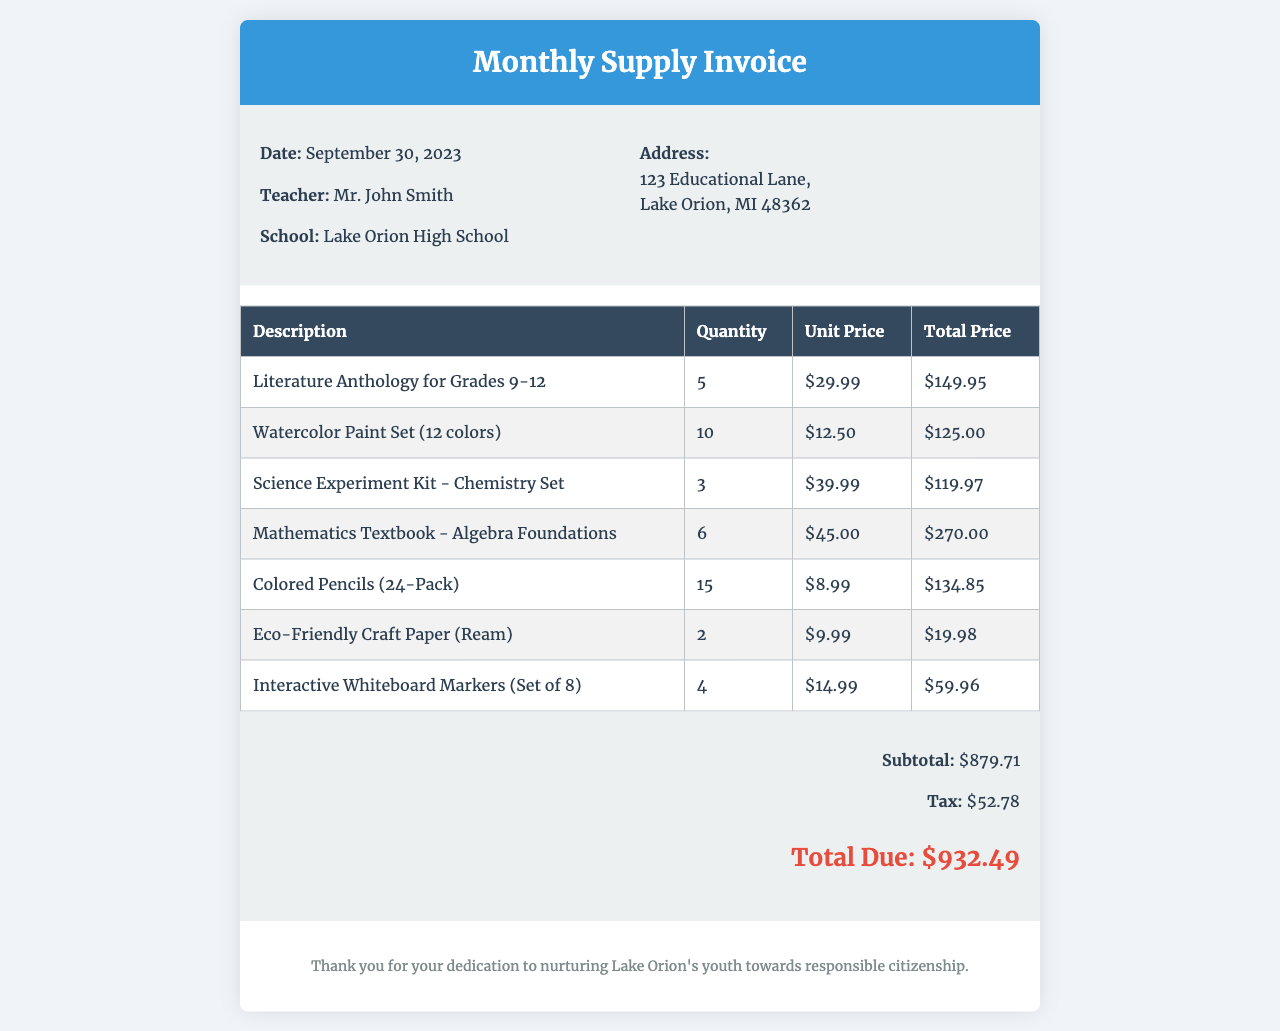What is the total amount due? The total amount due can be found in the invoice summary, which summarizes the total amount including tax, which is $932.49.
Answer: $932.49 Who is the teacher listed on the invoice? The teacher's name is provided in the invoice details section, which mentions Mr. John Smith.
Answer: Mr. John Smith When was the invoice dated? The date of the invoice is specified in the invoice details section, stating September 30, 2023.
Answer: September 30, 2023 How many units of Colored Pencils were ordered? The quantity of Colored Pencils is given in the invoice table under the 'Quantity' column, which shows 15 units.
Answer: 15 What is the subtotal before tax? The subtotal is provided in the invoice summary section, which indicates that the subtotal is $879.71.
Answer: $879.71 What school is this invoice for? The school name is mentioned in the invoice details section, which lists Lake Orion High School.
Answer: Lake Orion High School How many Literature Anthologies were purchased? The total number of Literature Anthologies is given in the invoice table, which states that 5 were purchased.
Answer: 5 How much does the Science Experiment Kit cost per unit? The unit price for the Science Experiment Kit is found in the invoice table, which lists the cost as $39.99.
Answer: $39.99 What type of markers were ordered? The description of markers is detailed in the invoice table, indicating that Interactive Whiteboard Markers were ordered.
Answer: Interactive Whiteboard Markers 